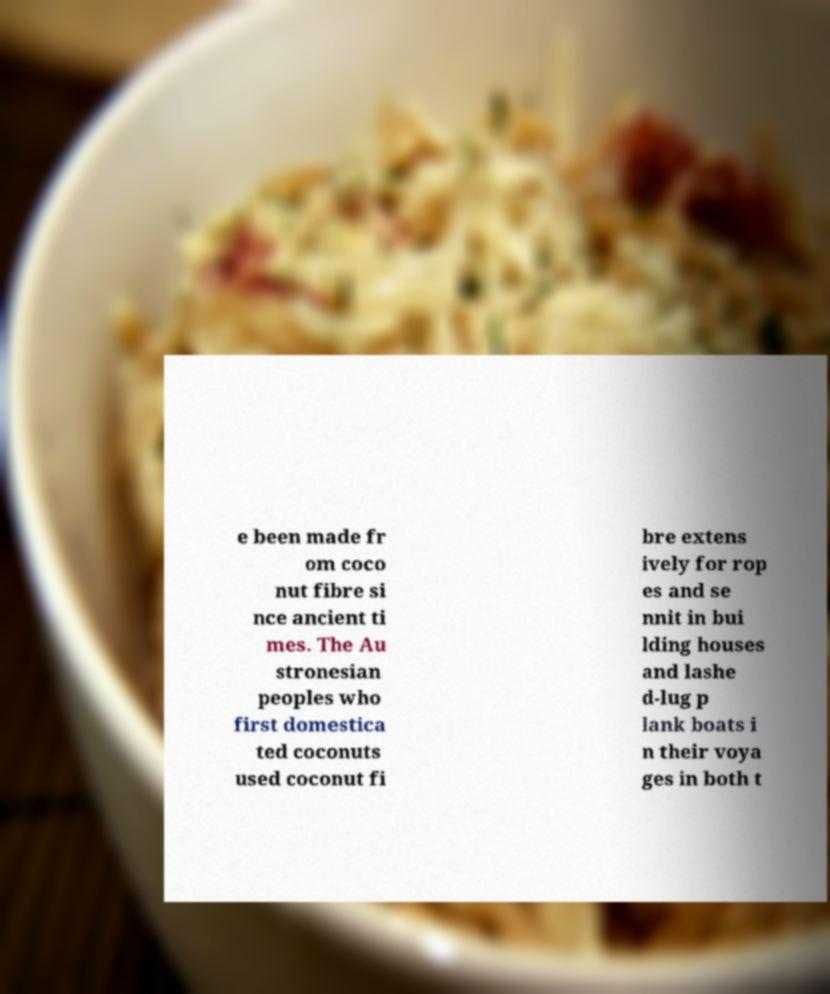Could you extract and type out the text from this image? e been made fr om coco nut fibre si nce ancient ti mes. The Au stronesian peoples who first domestica ted coconuts used coconut fi bre extens ively for rop es and se nnit in bui lding houses and lashe d-lug p lank boats i n their voya ges in both t 